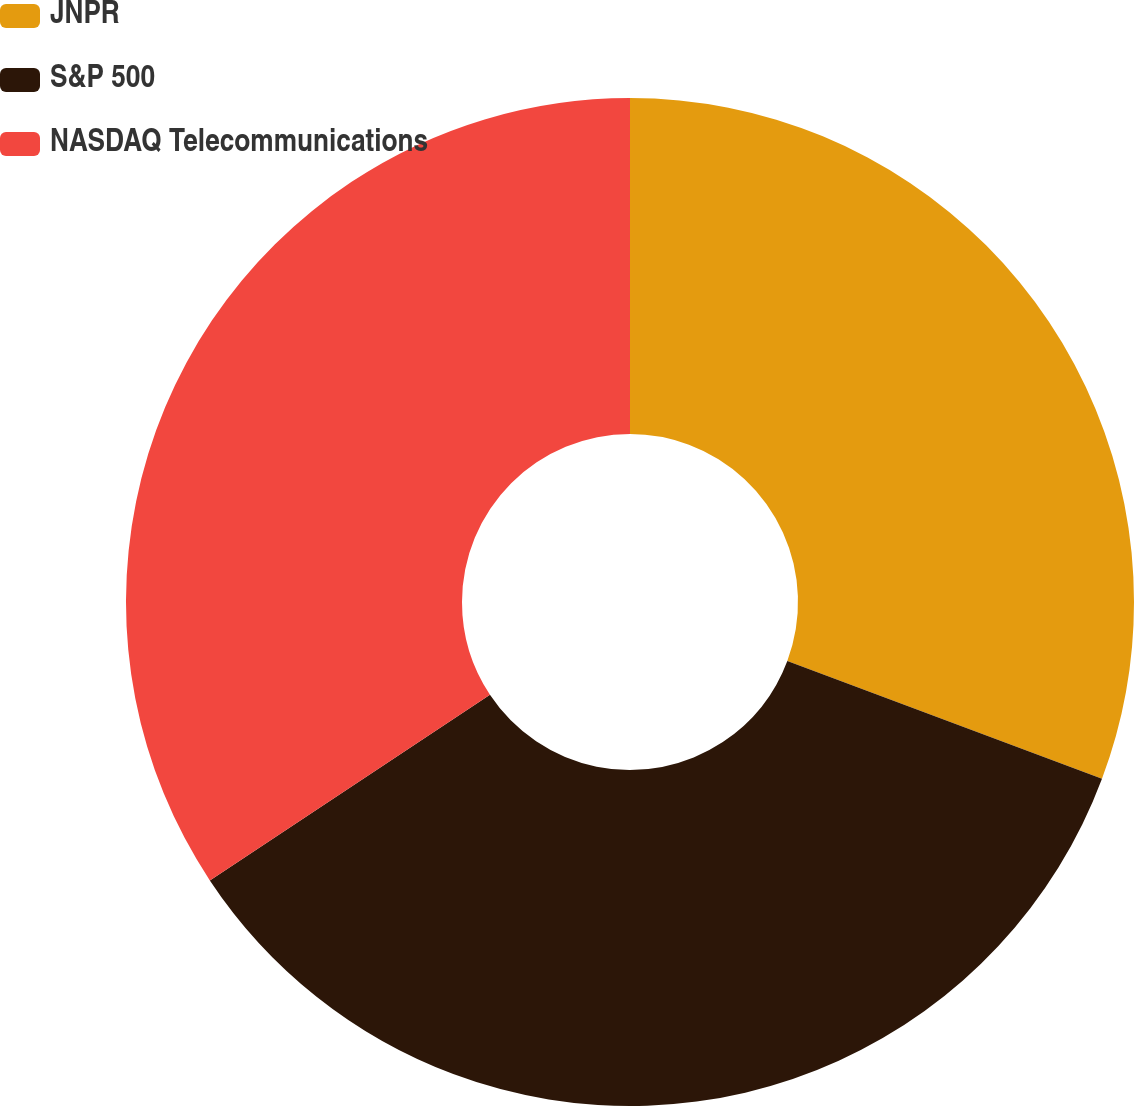<chart> <loc_0><loc_0><loc_500><loc_500><pie_chart><fcel>JNPR<fcel>S&P 500<fcel>NASDAQ Telecommunications<nl><fcel>30.7%<fcel>34.98%<fcel>34.31%<nl></chart> 